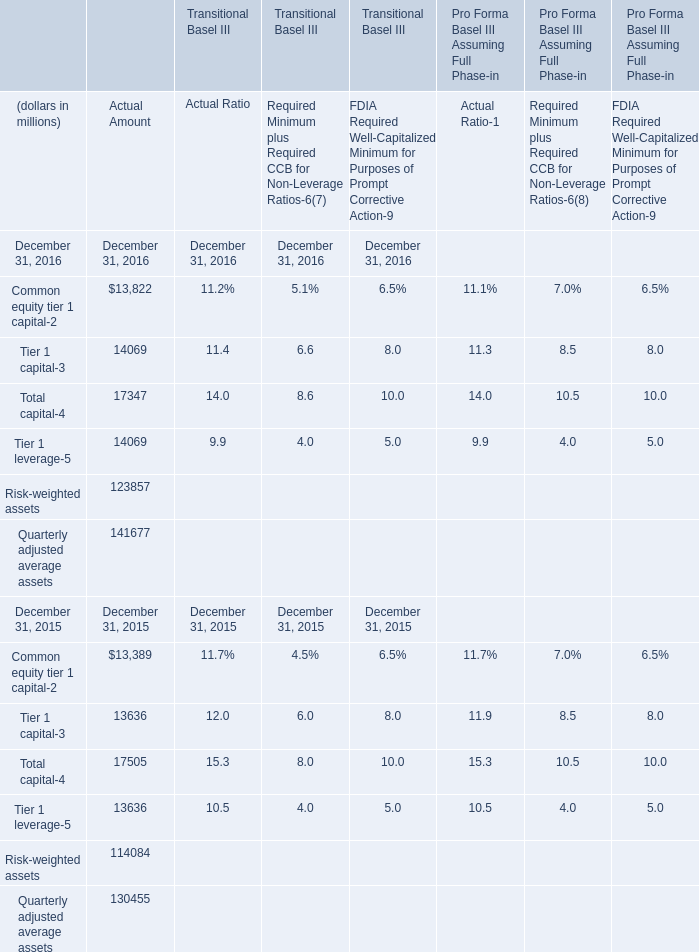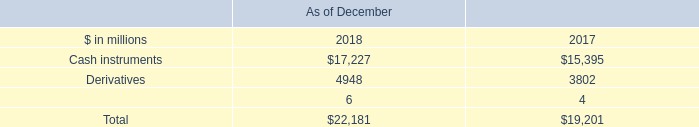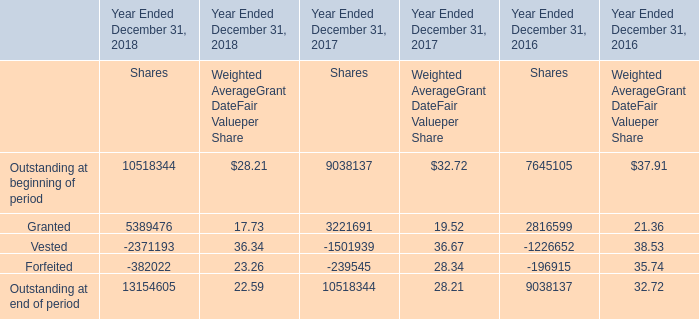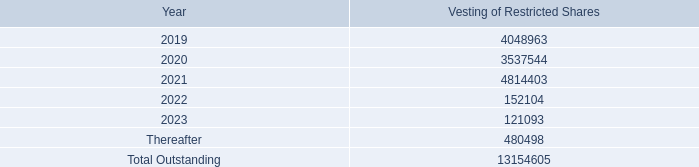what's the total amount of Granted of Year Ended December 31, 2016 Shares, Thereafter of Vesting of Restricted Shares 4,048,963 3,537,544 4,814,403, and Quarterly adjusted average assets of Transitional Basel III Actual Amount December 31, 2016 ? 
Computations: ((2816599.0 + 480498.0) + 141677.0)
Answer: 3438774.0. 